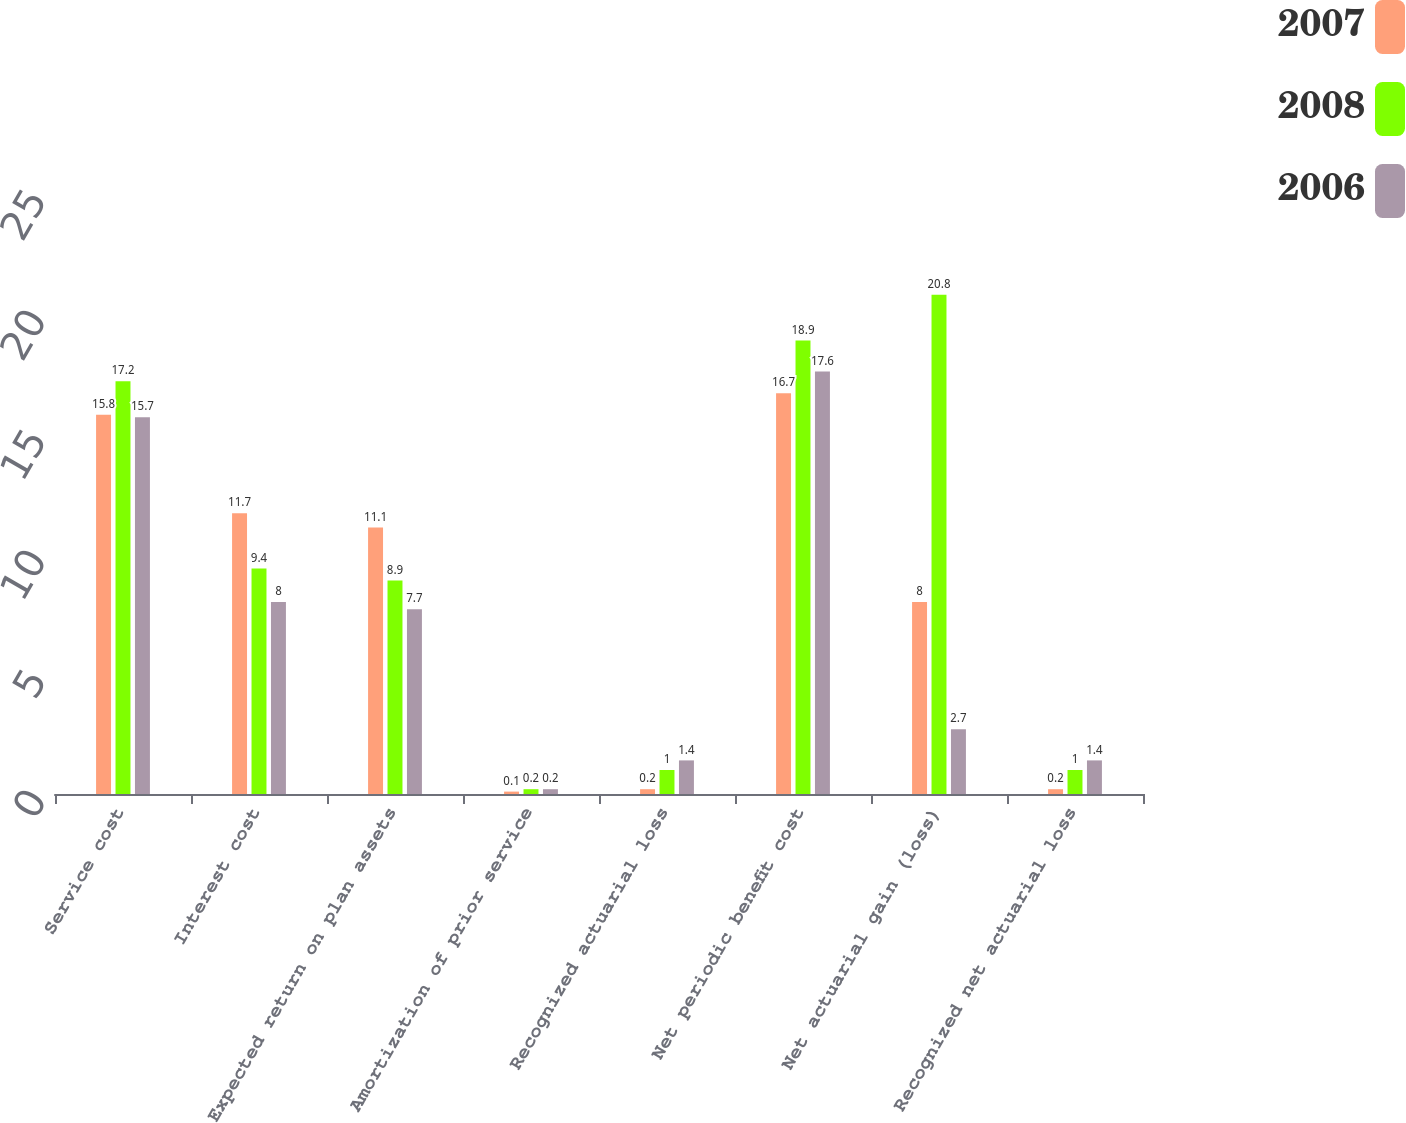<chart> <loc_0><loc_0><loc_500><loc_500><stacked_bar_chart><ecel><fcel>Service cost<fcel>Interest cost<fcel>Expected return on plan assets<fcel>Amortization of prior service<fcel>Recognized actuarial loss<fcel>Net periodic benefit cost<fcel>Net actuarial gain (loss)<fcel>Recognized net actuarial loss<nl><fcel>2007<fcel>15.8<fcel>11.7<fcel>11.1<fcel>0.1<fcel>0.2<fcel>16.7<fcel>8<fcel>0.2<nl><fcel>2008<fcel>17.2<fcel>9.4<fcel>8.9<fcel>0.2<fcel>1<fcel>18.9<fcel>20.8<fcel>1<nl><fcel>2006<fcel>15.7<fcel>8<fcel>7.7<fcel>0.2<fcel>1.4<fcel>17.6<fcel>2.7<fcel>1.4<nl></chart> 